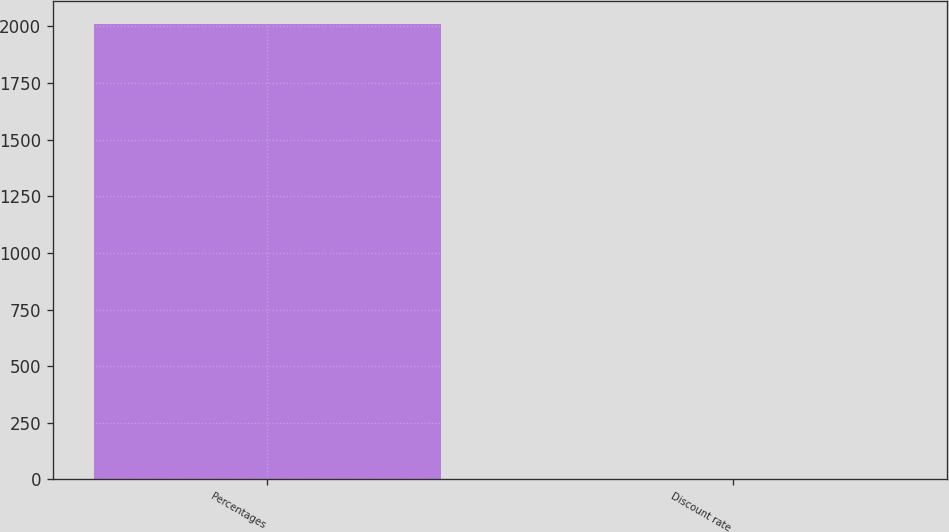Convert chart. <chart><loc_0><loc_0><loc_500><loc_500><bar_chart><fcel>Percentages<fcel>Discount rate<nl><fcel>2012<fcel>3.67<nl></chart> 